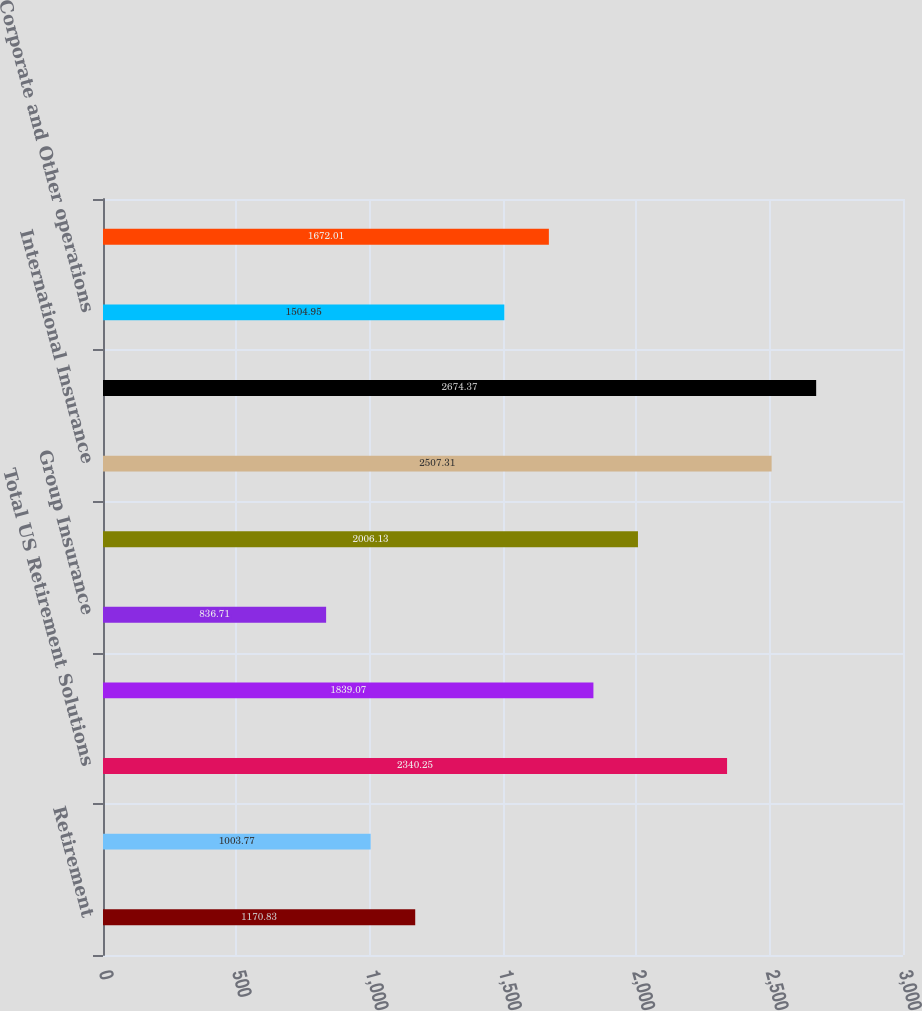<chart> <loc_0><loc_0><loc_500><loc_500><bar_chart><fcel>Retirement<fcel>Asset Management<fcel>Total US Retirement Solutions<fcel>Individual Life<fcel>Group Insurance<fcel>Total US Individual Life and<fcel>International Insurance<fcel>Total International Insurance<fcel>Corporate and Other operations<fcel>Total Corporate and Other<nl><fcel>1170.83<fcel>1003.77<fcel>2340.25<fcel>1839.07<fcel>836.71<fcel>2006.13<fcel>2507.31<fcel>2674.37<fcel>1504.95<fcel>1672.01<nl></chart> 